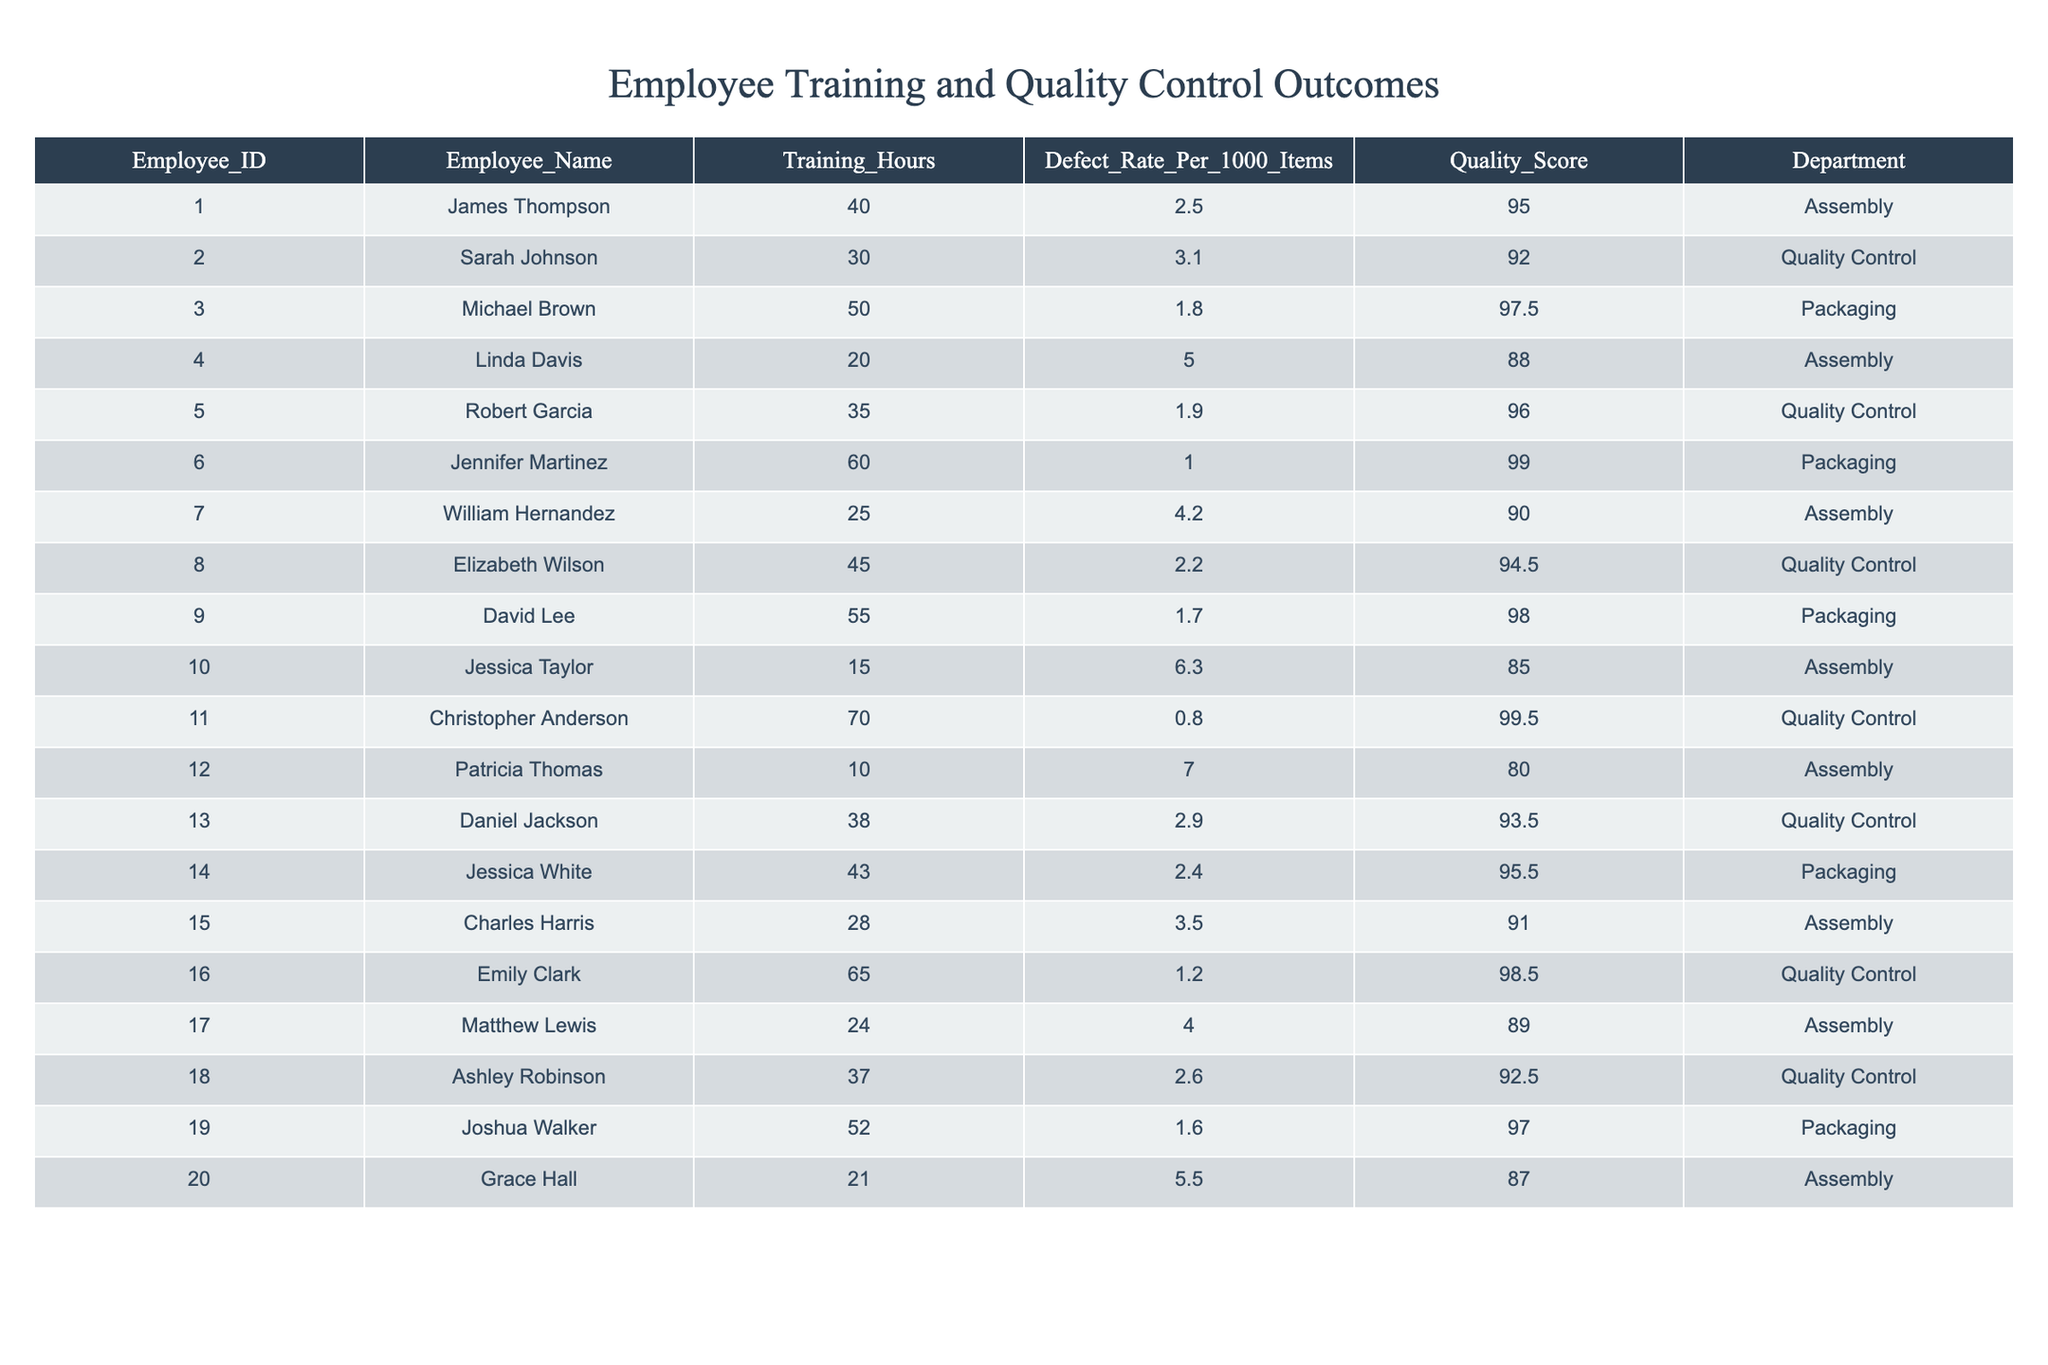What is the defect rate of employee James Thompson? According to the table, James Thompson has a defect rate of 2.5 per 1000 items.
Answer: 2.5 How many training hours did Linda Davis complete? The table shows that Linda Davis completed 20 training hours.
Answer: 20 Which employee has the highest quality score? The highest quality score in the table is 99.5, achieved by Christopher Anderson.
Answer: Christopher Anderson What is the average defect rate across all employees? To find the average defect rate, sum all the defect rates (2.5 + 3.1 + 1.8 + 5.0 + 1.9 + 1.0 + 4.2 + 2.2 + 1.7 + 6.3 + 0.8 + 7.0 + 2.9 + 2.4 + 3.5 + 1.2 + 4.0 + 2.6 + 1.6 + 5.5) = 45.2. There are 20 employees, so the average defect rate is 45.2 / 20 = 2.26.
Answer: 2.26 Is there an employee who has both the highest training hours and the lowest defect rate? Yes, Christopher Anderson has the highest training hours of 70 and the lowest defect rate of 0.8.
Answer: Yes What is the difference in quality scores between the employee with the most training hours and the employee with the fewest? The employee with the most training hours is Christopher Anderson (99.5) and the one with the fewest is Patricia Thomas (80.0). The difference is 99.5 - 80.0 = 19.5.
Answer: 19.5 Which department has the employee with the most training hours? Christopher Anderson from the Quality Control department has the most training hours at 70.
Answer: Quality Control How many employees have a defect rate below 2.0? Reviewing the defect rates, the employees below 2.0 are Michael Brown (1.8), Jennifer Martinez (1.0), David Lee (1.7), and Joshua Walker (1.6). There are 4 employees with a defect rate below 2.0.
Answer: 4 What is the quality score of the employee with the least training hours? Patricia Thomas has the least training hours at 10, and her quality score is 80.0.
Answer: 80.0 If an employee increases their training hours by 10, how might that affect their defect rate based on the data? Evaluating the data, some employees with more training hours tend to have lower defect rates; however, this isn't a definitive trend as individual performance varies. Therefore, an increase could lead to a decrease, but it is not guaranteed.
Answer: It may decrease, but not guaranteed Which employee worked in the Packaging department and had a defect rate of 1.7? David Lee is the employee from the Packaging department with a defect rate of 1.7.
Answer: David Lee 